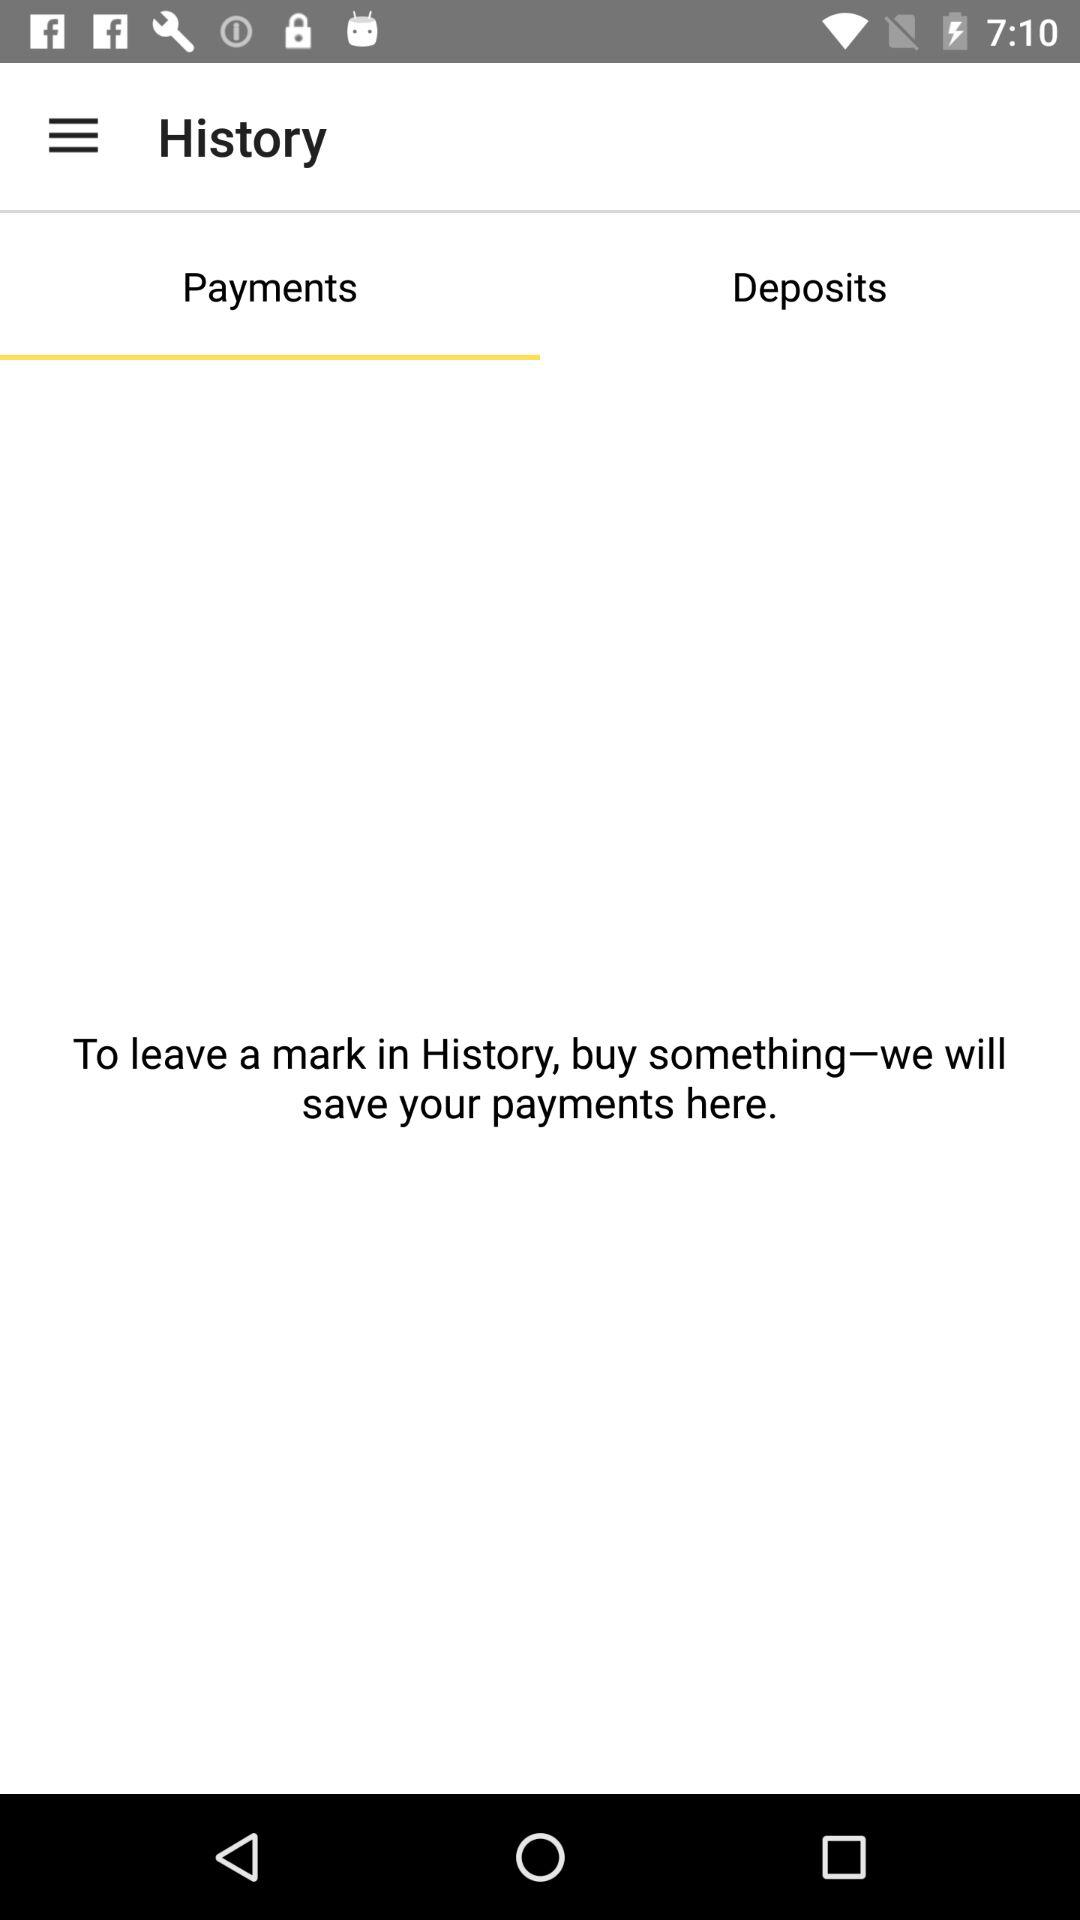What tab am I on? You are on the "Payments" tab. 